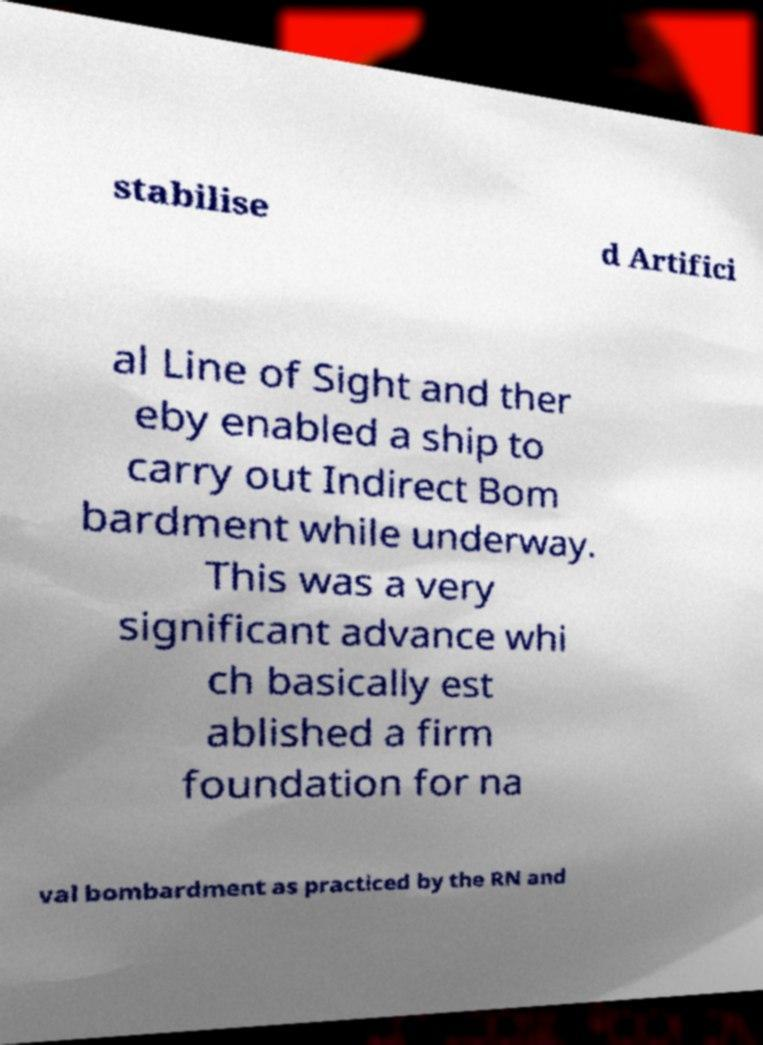For documentation purposes, I need the text within this image transcribed. Could you provide that? stabilise d Artifici al Line of Sight and ther eby enabled a ship to carry out Indirect Bom bardment while underway. This was a very significant advance whi ch basically est ablished a firm foundation for na val bombardment as practiced by the RN and 